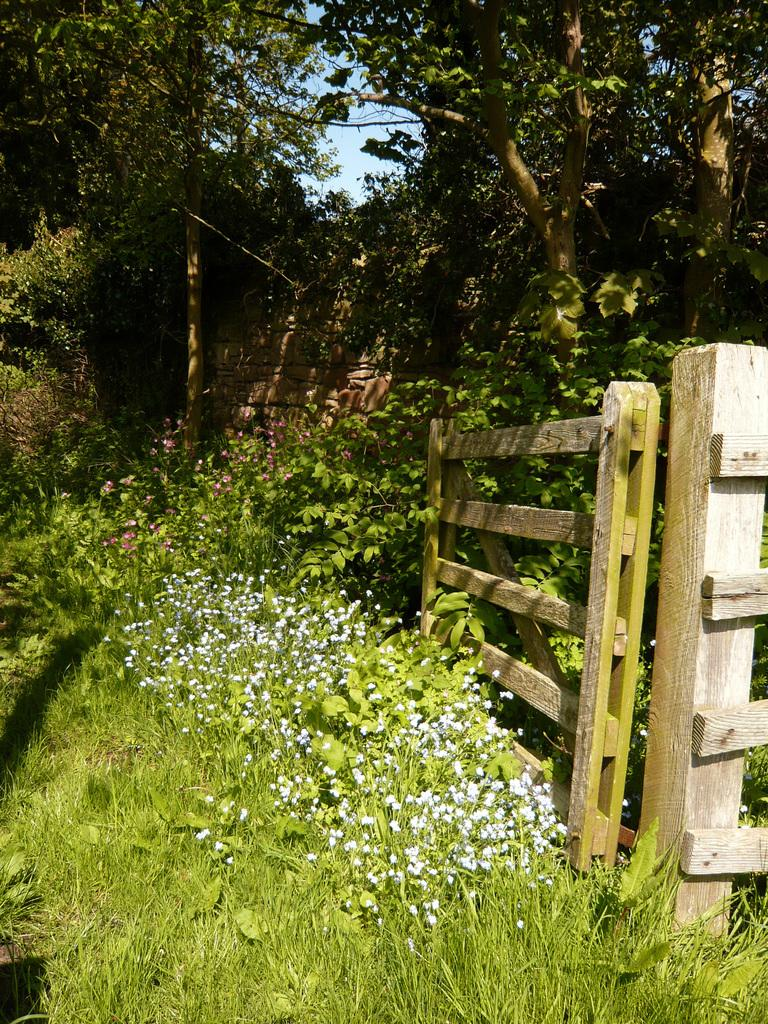What type of barrier can be seen on the grassland in the image? There is a fence on the grassland in the image. What kind of vegetation is present on the grassland? There are plants with flowers on the grassland. What structure is visible in the image? There is a wall in the image. What can be seen in the background of the image? There are trees and the sky visible in the background. How many women are participating in the battle depicted in the image? There is no battle or women present in the image. What type of pets can be seen playing with the plants on the grassland? There are no pets present in the image; it features a fence, plants with flowers, a wall, trees, and the sky. 